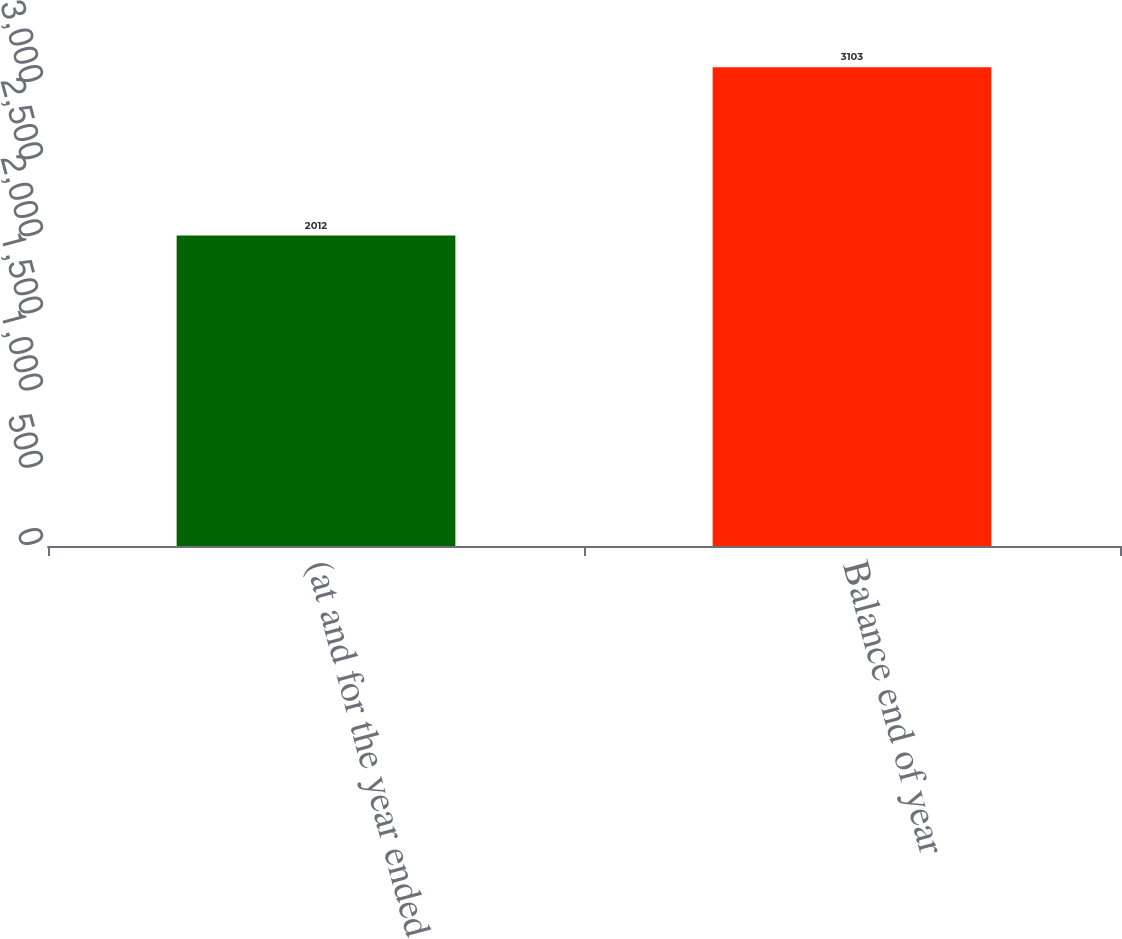Convert chart. <chart><loc_0><loc_0><loc_500><loc_500><bar_chart><fcel>(at and for the year ended<fcel>Balance end of year<nl><fcel>2012<fcel>3103<nl></chart> 